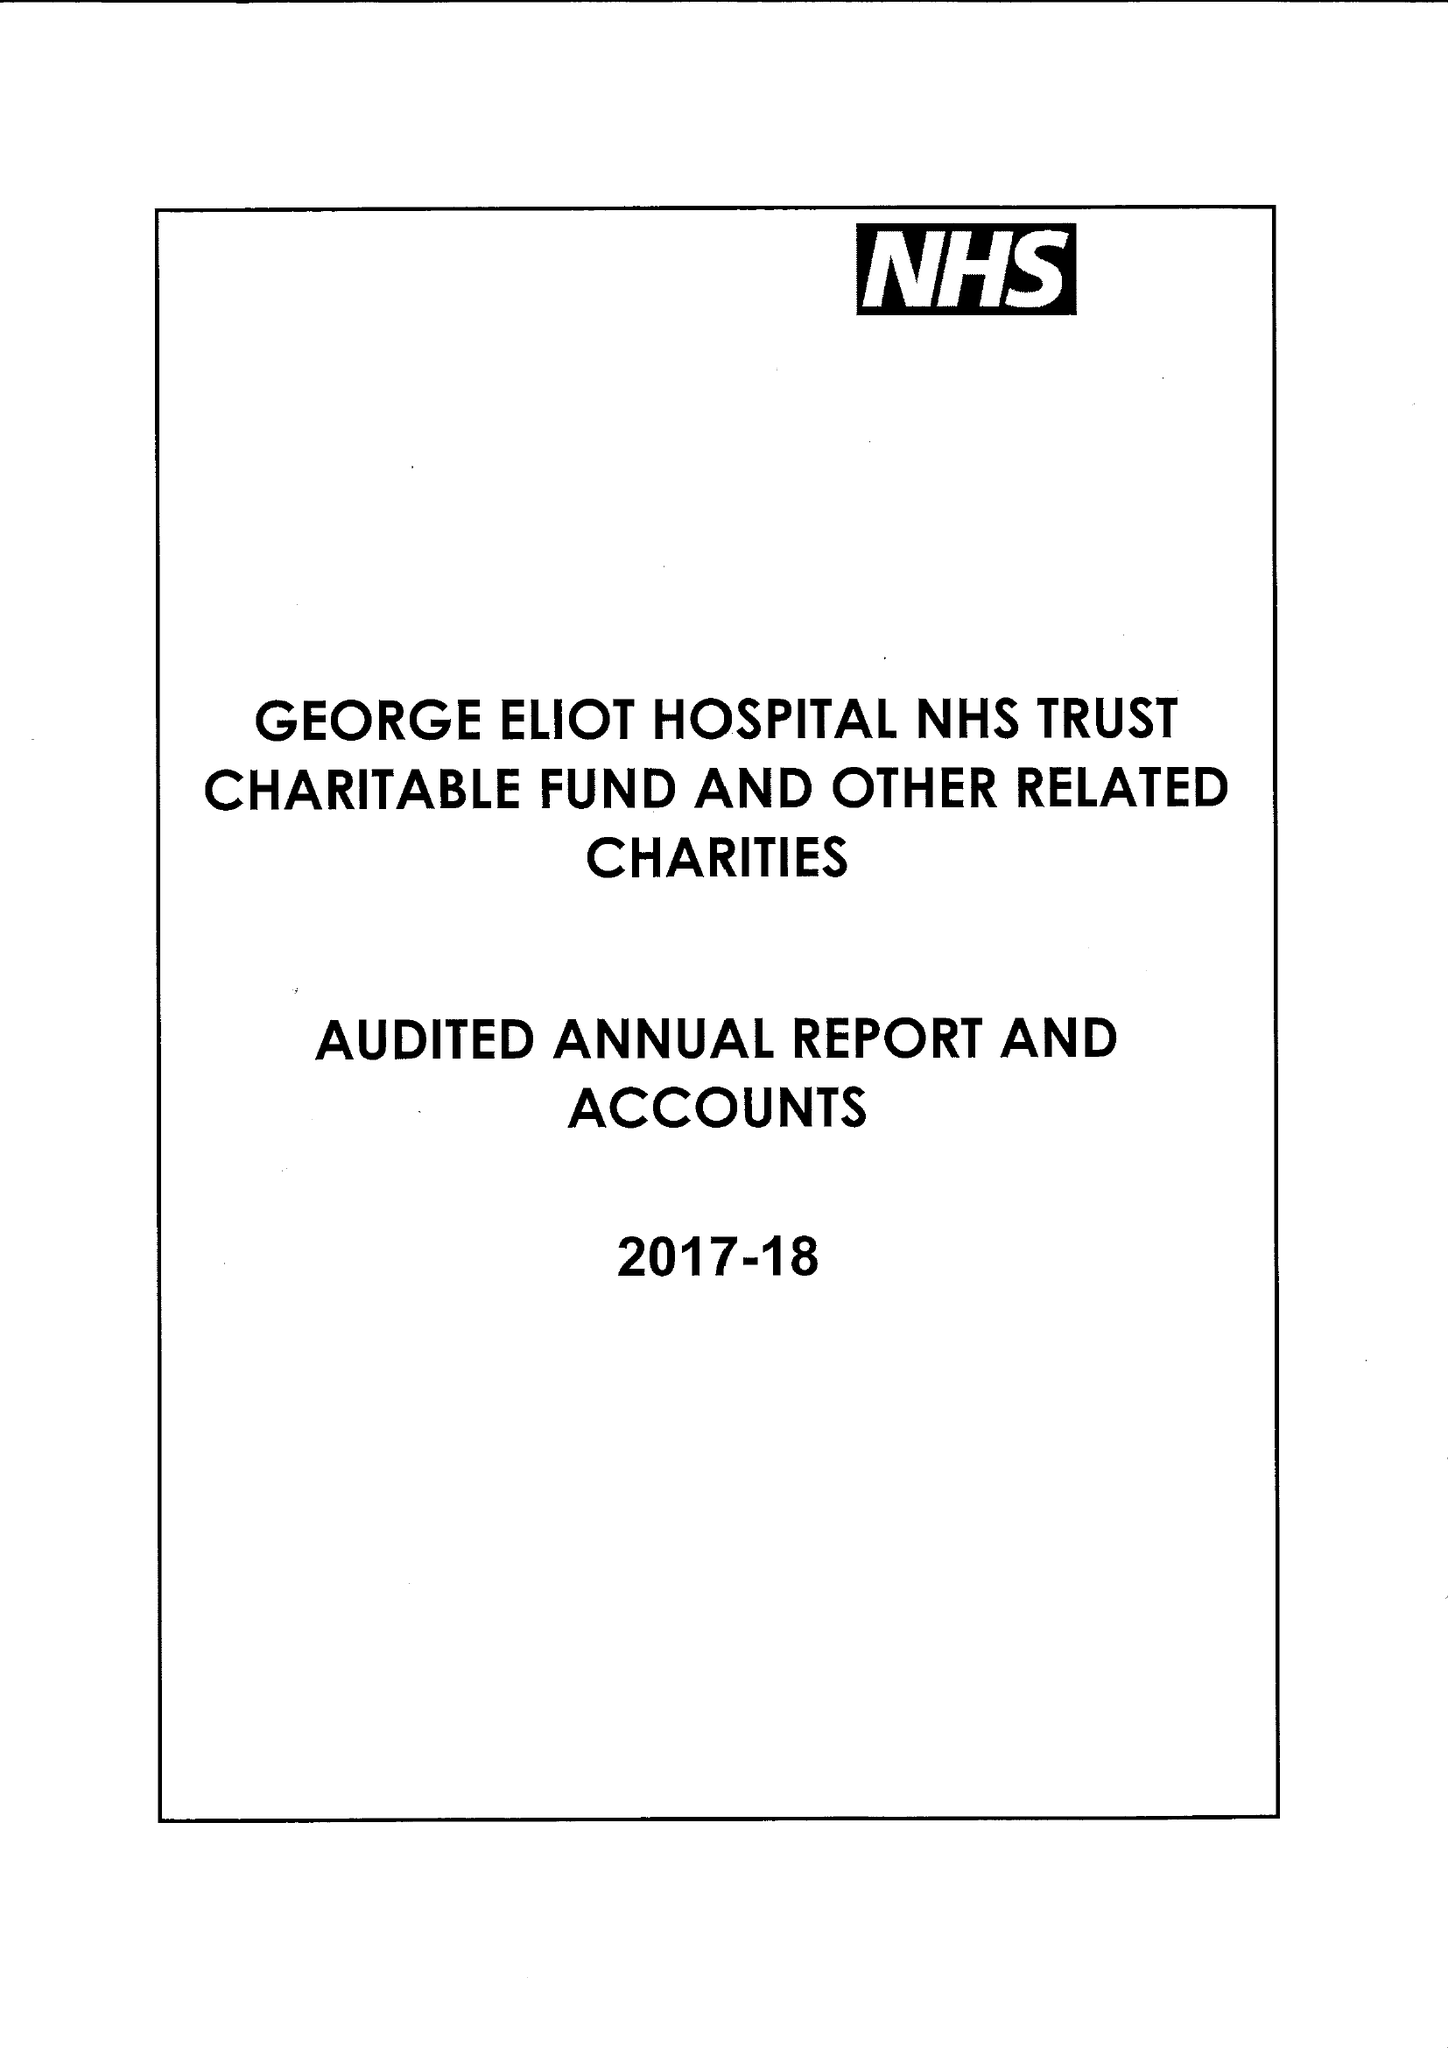What is the value for the address__postcode?
Answer the question using a single word or phrase. CV10 7DJ 